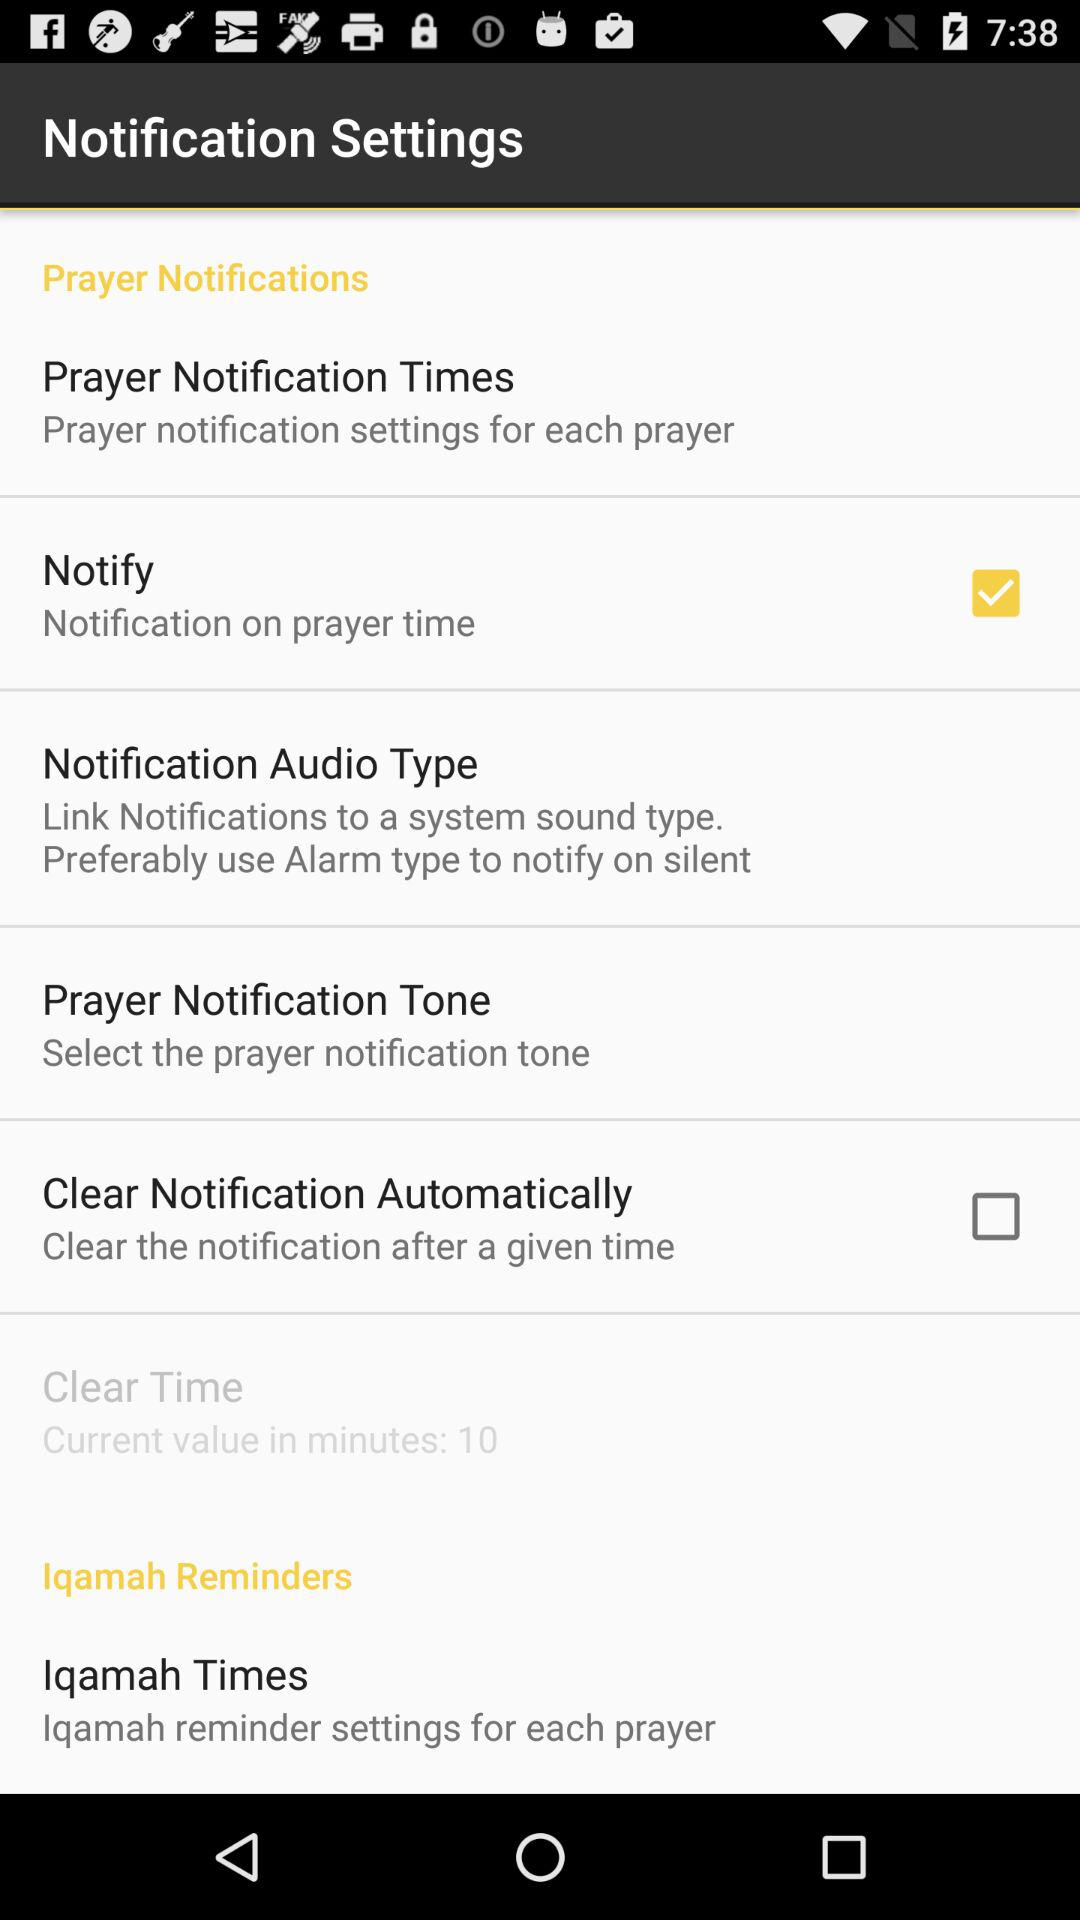How many minutes is the default Clear Time value?
Answer the question using a single word or phrase. 10 